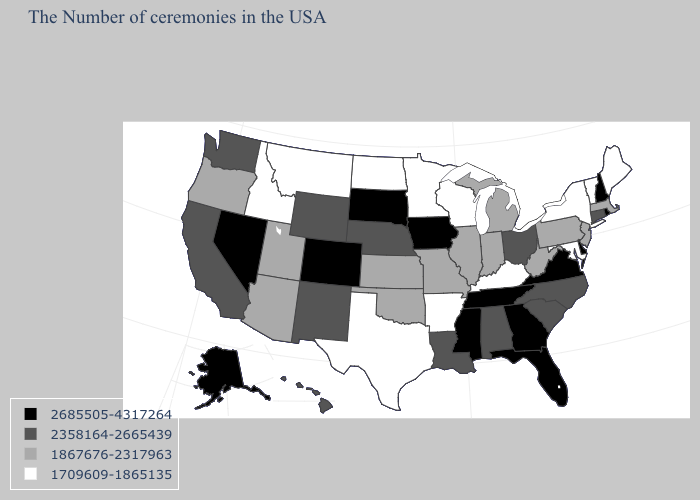Among the states that border South Dakota , which have the lowest value?
Keep it brief. Minnesota, North Dakota, Montana. Among the states that border Mississippi , which have the highest value?
Keep it brief. Tennessee. Does Rhode Island have the highest value in the USA?
Short answer required. Yes. What is the value of Pennsylvania?
Quick response, please. 1867676-2317963. What is the highest value in the Northeast ?
Short answer required. 2685505-4317264. Does New Jersey have the highest value in the USA?
Concise answer only. No. What is the value of New Mexico?
Short answer required. 2358164-2665439. What is the lowest value in the MidWest?
Write a very short answer. 1709609-1865135. What is the value of Nevada?
Keep it brief. 2685505-4317264. What is the value of Arizona?
Keep it brief. 1867676-2317963. How many symbols are there in the legend?
Concise answer only. 4. How many symbols are there in the legend?
Keep it brief. 4. Does Connecticut have the lowest value in the Northeast?
Answer briefly. No. Among the states that border North Dakota , which have the lowest value?
Quick response, please. Minnesota, Montana. Name the states that have a value in the range 1867676-2317963?
Be succinct. Massachusetts, New Jersey, Pennsylvania, West Virginia, Michigan, Indiana, Illinois, Missouri, Kansas, Oklahoma, Utah, Arizona, Oregon. 